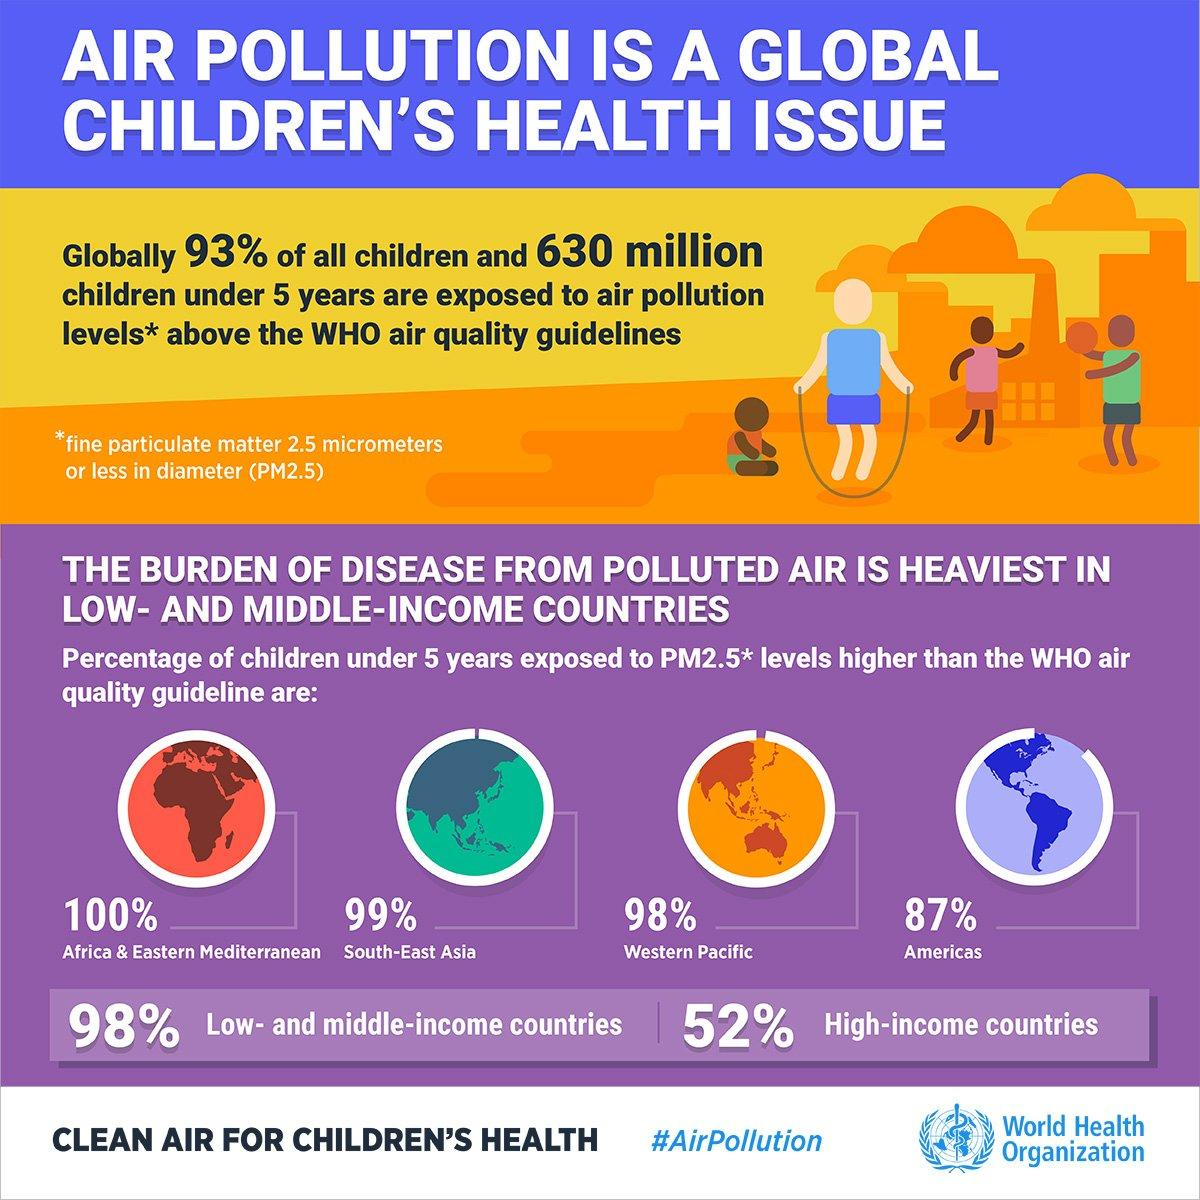List a handful of essential elements in this visual. In the Western Pacific region, only 2% of children under the age of five are not exposed to air pollution. According to recent data, only 7% of children under the age of five are not exposed to air pollution. According to recent studies, only 2% of children in low and middle-income countries are not exposed to air pollution. According to recent data, a significant portion of children under the age of five in America have not been exposed to harmful levels of air pollution. Specifically, approximately 13% of children in this age group are able to avoid air pollution altogether. This is a positive development and reflects efforts to improve air quality and protect the health of young children. In the South-East Asia region, only 1% of children under the age of five are not exposed to air pollution. 